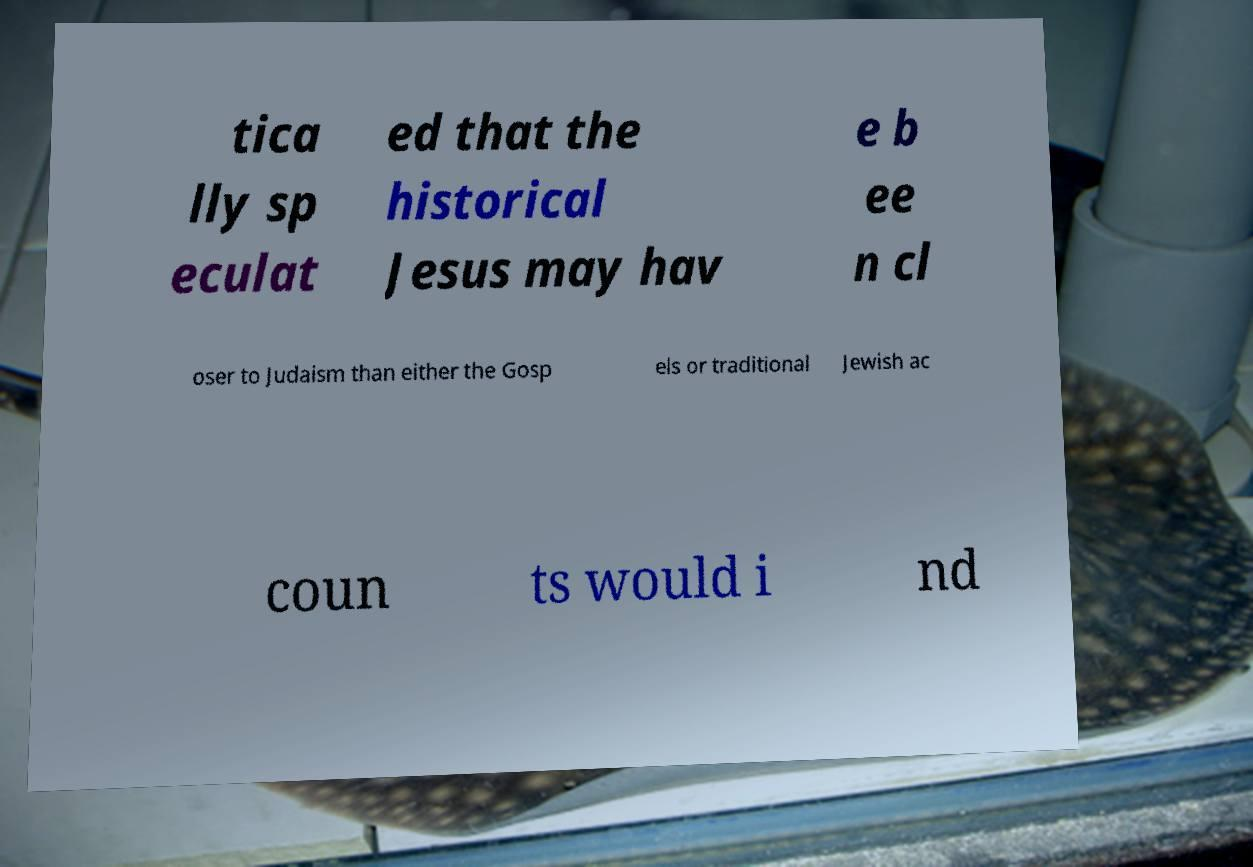Please read and relay the text visible in this image. What does it say? tica lly sp eculat ed that the historical Jesus may hav e b ee n cl oser to Judaism than either the Gosp els or traditional Jewish ac coun ts would i nd 